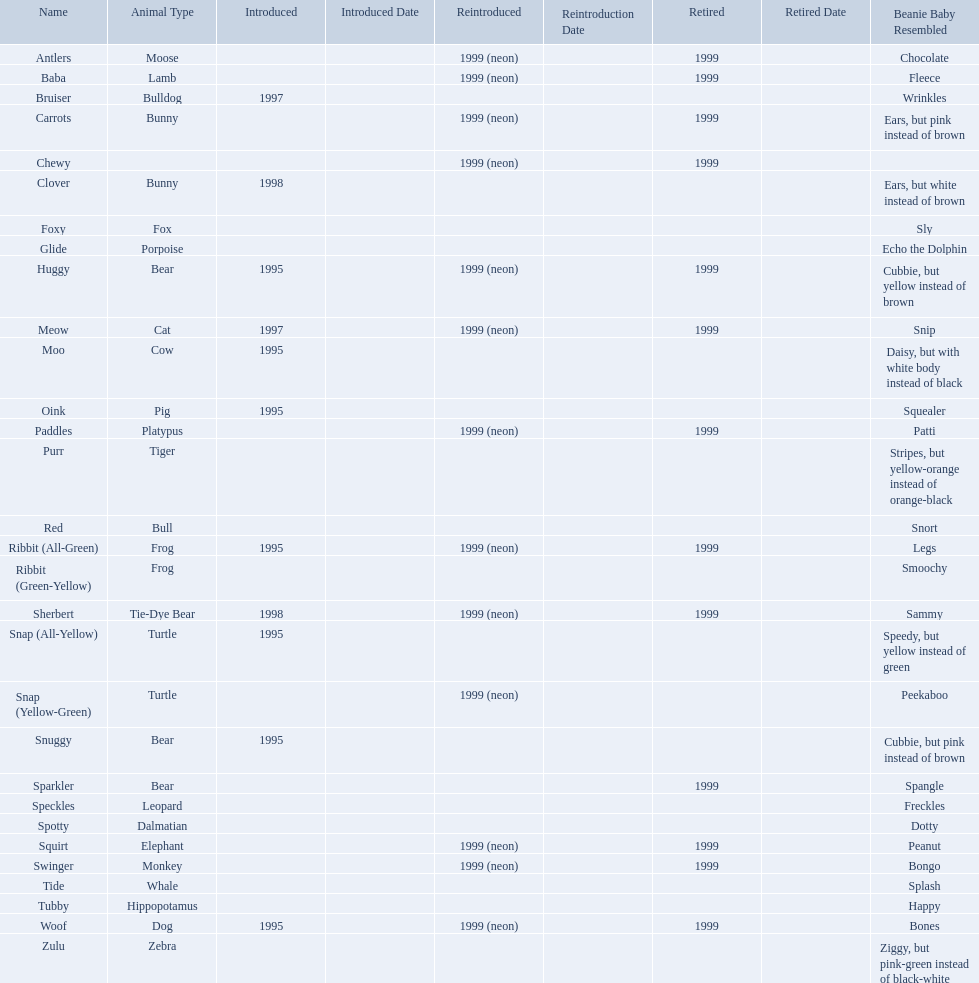What are the types of pillow pal animals? Antlers, Moose, Lamb, Bulldog, Bunny, , Bunny, Fox, Porpoise, Bear, Cat, Cow, Pig, Platypus, Tiger, Bull, Frog, Frog, Tie-Dye Bear, Turtle, Turtle, Bear, Bear, Leopard, Dalmatian, Elephant, Monkey, Whale, Hippopotamus, Dog, Zebra. Of those, which is a dalmatian? Dalmatian. What is the name of the dalmatian? Spotty. What are the names listed? Antlers, Baba, Bruiser, Carrots, Chewy, Clover, Foxy, Glide, Huggy, Meow, Moo, Oink, Paddles, Purr, Red, Ribbit (All-Green), Ribbit (Green-Yellow), Sherbert, Snap (All-Yellow), Snap (Yellow-Green), Snuggy, Sparkler, Speckles, Spotty, Squirt, Swinger, Tide, Tubby, Woof, Zulu. Of these, which is the only pet without an animal type listed? Chewy. What are all the pillow pals? Antlers, Baba, Bruiser, Carrots, Chewy, Clover, Foxy, Glide, Huggy, Meow, Moo, Oink, Paddles, Purr, Red, Ribbit (All-Green), Ribbit (Green-Yellow), Sherbert, Snap (All-Yellow), Snap (Yellow-Green), Snuggy, Sparkler, Speckles, Spotty, Squirt, Swinger, Tide, Tubby, Woof, Zulu. Which is the only without a listed animal type? Chewy. 